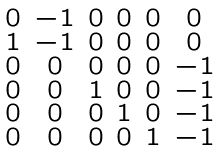<formula> <loc_0><loc_0><loc_500><loc_500>\begin{smallmatrix} 0 & - 1 & 0 & 0 & 0 & 0 \\ 1 & - 1 & 0 & 0 & 0 & 0 \\ 0 & 0 & 0 & 0 & 0 & - 1 \\ 0 & 0 & 1 & 0 & 0 & - 1 \\ 0 & 0 & 0 & 1 & 0 & - 1 \\ 0 & 0 & 0 & 0 & 1 & - 1 \end{smallmatrix}</formula> 